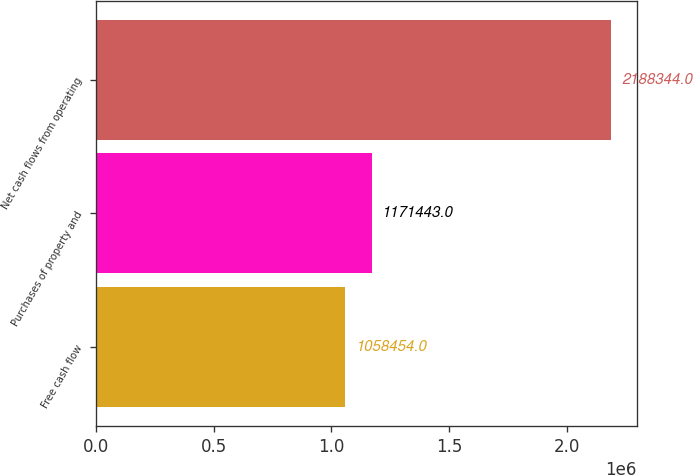Convert chart. <chart><loc_0><loc_0><loc_500><loc_500><bar_chart><fcel>Free cash flow<fcel>Purchases of property and<fcel>Net cash flows from operating<nl><fcel>1.05845e+06<fcel>1.17144e+06<fcel>2.18834e+06<nl></chart> 